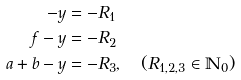<formula> <loc_0><loc_0><loc_500><loc_500>- y & = - R _ { 1 } \\ f - y & = - R _ { 2 } \\ a + b - y & = - R _ { 3 } , \quad ( R _ { 1 , 2 , 3 } \in \mathbb { N } _ { 0 } )</formula> 